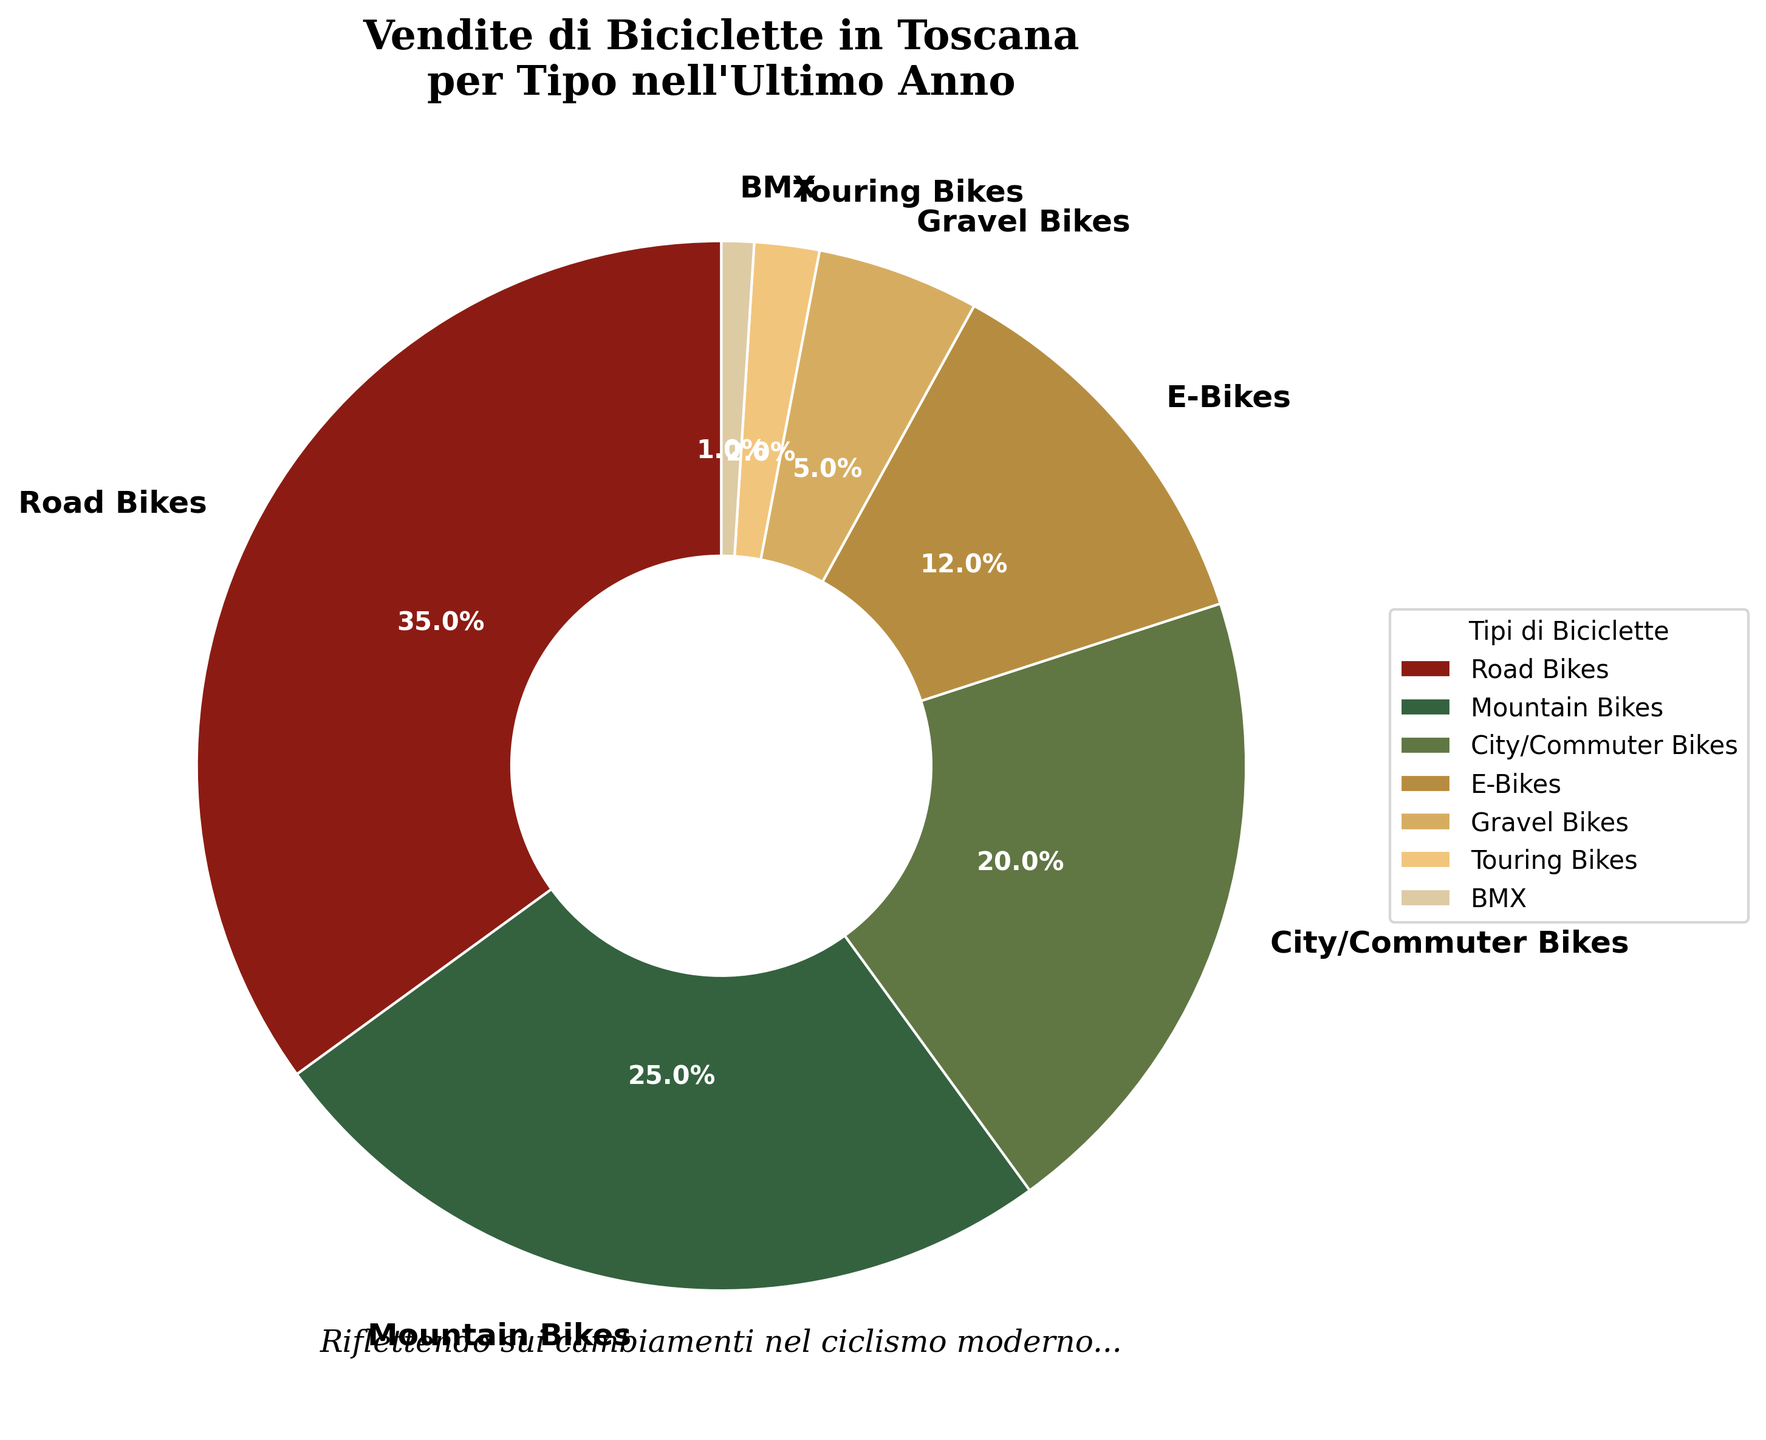What is the most popular type of bicycle sold in Tuscany over the last year? The pie chart shows that the segment representing Road Bikes is the largest, indicating it has the highest percentage of sales at 35%.
Answer: Road Bikes What is the difference in sales percentage between Mountain Bikes and E-Bikes? Mountain Bikes have a sales percentage of 25%, and E-Bikes have 12%. The difference is calculated as 25% - 12% = 13%.
Answer: 13% Which type of bike has the smallest share of sales, and how much is it? The smallest segment in the pie chart is labeled BMX, which accounts for 1% of the total sales.
Answer: BMX, 1% How many types of bicycles have a sales percentage higher than 10%? By examining the pie chart, we can see that Road Bikes (35%), Mountain Bikes (25%), City/Commuter Bikes (20%), and E-Bikes (12%) are the four types with sales percentages exceeding 10%.
Answer: 4 What is the combined sales percentage of City/Commuter Bikes and Gravel Bikes? City/Commuter Bikes have a sales percentage of 20%, and Gravel Bikes have 5%. Adding them together yields 20% + 5% = 25%.
Answer: 25% How do the sales percentages of Road Bikes and Mountain Bikes compare? Road Bikes have a sales percentage of 35%, and Mountain Bikes have 25%. Road Bikes sell 10% more than Mountain Bikes.
Answer: Road Bikes sell 10% more Which color represents E-Bikes, and where is it located? The color representing E-Bikes is located on the pie chart wedge indicated by the label for E-Bikes. This segment is of a golden yellow color and occupies 12% of the chart, positioned around the lower-right part starting from the bottom.
Answer: Golden yellow, lower-right How much more popular are City/Commuter Bikes compared to Touring Bikes? City/Commuter Bikes have a sales percentage of 20%, while Touring Bikes have 2%. The difference is calculated as 20% - 2% = 18%.
Answer: 18% What is the total sales percentage for BMX and Touring Bikes combined? BMX sales are 1%, and Touring Bikes are 2%. Adding them together gives 1% + 2% = 3%.
Answer: 3% If the combined percentages of E-Bikes and Gravel Bikes are summed, will they exceed the sales percentage of Mountain Bikes? E-Bikes have a sales percentage of 12%, and Gravel Bikes are at 5%. Their combined total is 12% + 5% = 17%, which is less than Mountain Bikes' 25%.
Answer: No, they do not exceed Mountain Bikes 